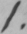What text is written in this handwritten line? 1 . 